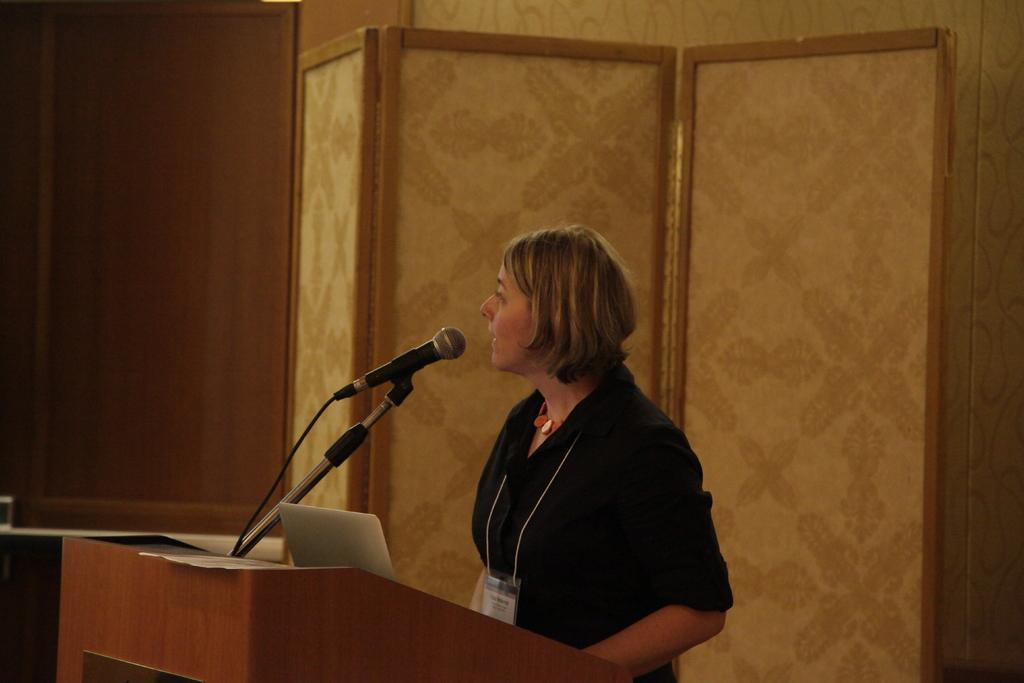What is the main object on the stage in the image? There is a podium in the image. What is on the podium? There is a microphone on the podium. Who is standing in front of the podium? There is a woman standing in front of the podium. What can be seen behind the woman and the podium? There is a wall in the background of the image. What type of grandmother is standing next to the podium in the image? There is no grandmother present in the image; it features a woman standing in front of the podium. 